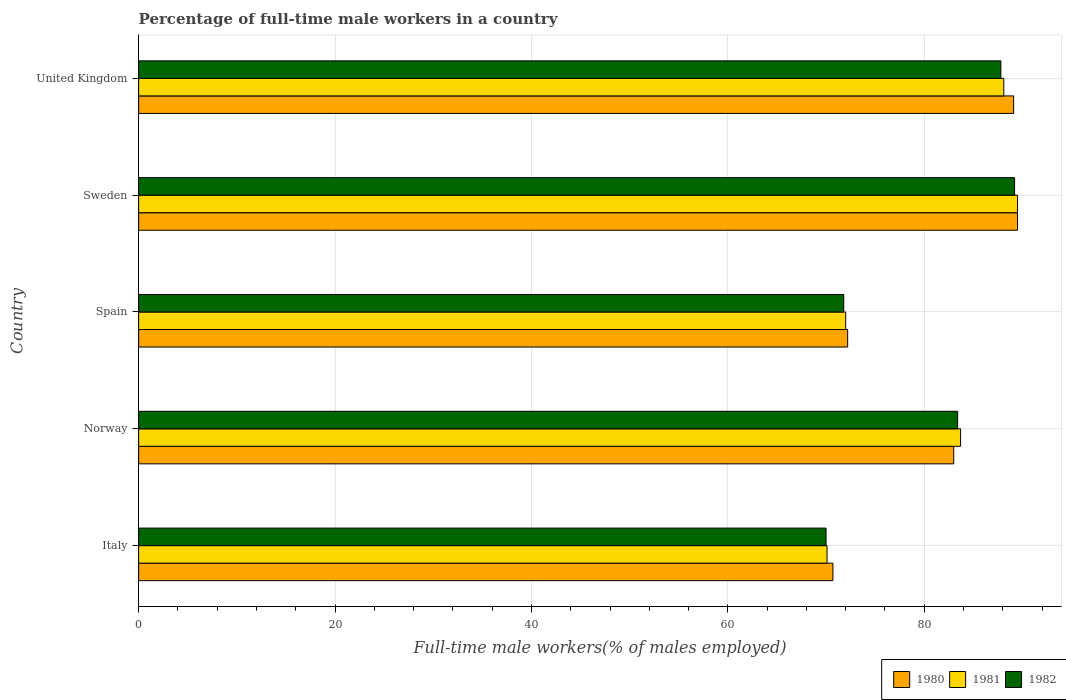How many different coloured bars are there?
Keep it short and to the point. 3. Are the number of bars per tick equal to the number of legend labels?
Give a very brief answer. Yes. Are the number of bars on each tick of the Y-axis equal?
Offer a very short reply. Yes. How many bars are there on the 2nd tick from the top?
Offer a terse response. 3. How many bars are there on the 3rd tick from the bottom?
Keep it short and to the point. 3. What is the percentage of full-time male workers in 1982 in Spain?
Provide a short and direct response. 71.8. Across all countries, what is the maximum percentage of full-time male workers in 1981?
Offer a terse response. 89.5. Across all countries, what is the minimum percentage of full-time male workers in 1981?
Offer a terse response. 70.1. In which country was the percentage of full-time male workers in 1981 maximum?
Your answer should be compact. Sweden. In which country was the percentage of full-time male workers in 1982 minimum?
Keep it short and to the point. Italy. What is the total percentage of full-time male workers in 1982 in the graph?
Offer a very short reply. 402.2. What is the difference between the percentage of full-time male workers in 1982 in Italy and that in Norway?
Offer a very short reply. -13.4. What is the difference between the percentage of full-time male workers in 1981 in Spain and the percentage of full-time male workers in 1982 in Sweden?
Give a very brief answer. -17.2. What is the average percentage of full-time male workers in 1981 per country?
Your response must be concise. 80.68. What is the difference between the percentage of full-time male workers in 1980 and percentage of full-time male workers in 1981 in Spain?
Make the answer very short. 0.2. In how many countries, is the percentage of full-time male workers in 1982 greater than 56 %?
Offer a very short reply. 5. What is the ratio of the percentage of full-time male workers in 1981 in Italy to that in Sweden?
Provide a succinct answer. 0.78. Is the percentage of full-time male workers in 1980 in Italy less than that in United Kingdom?
Make the answer very short. Yes. What is the difference between the highest and the second highest percentage of full-time male workers in 1981?
Ensure brevity in your answer.  1.4. What is the difference between the highest and the lowest percentage of full-time male workers in 1982?
Keep it short and to the point. 19.2. In how many countries, is the percentage of full-time male workers in 1981 greater than the average percentage of full-time male workers in 1981 taken over all countries?
Provide a succinct answer. 3. What does the 3rd bar from the bottom in Sweden represents?
Offer a very short reply. 1982. Are all the bars in the graph horizontal?
Your answer should be very brief. Yes. How many countries are there in the graph?
Give a very brief answer. 5. What is the difference between two consecutive major ticks on the X-axis?
Your response must be concise. 20. Does the graph contain grids?
Give a very brief answer. Yes. Where does the legend appear in the graph?
Provide a short and direct response. Bottom right. How many legend labels are there?
Give a very brief answer. 3. What is the title of the graph?
Your answer should be very brief. Percentage of full-time male workers in a country. Does "2012" appear as one of the legend labels in the graph?
Offer a very short reply. No. What is the label or title of the X-axis?
Give a very brief answer. Full-time male workers(% of males employed). What is the Full-time male workers(% of males employed) of 1980 in Italy?
Provide a succinct answer. 70.7. What is the Full-time male workers(% of males employed) of 1981 in Italy?
Offer a very short reply. 70.1. What is the Full-time male workers(% of males employed) of 1981 in Norway?
Offer a terse response. 83.7. What is the Full-time male workers(% of males employed) in 1982 in Norway?
Provide a succinct answer. 83.4. What is the Full-time male workers(% of males employed) in 1980 in Spain?
Offer a very short reply. 72.2. What is the Full-time male workers(% of males employed) of 1982 in Spain?
Your answer should be very brief. 71.8. What is the Full-time male workers(% of males employed) of 1980 in Sweden?
Your answer should be very brief. 89.5. What is the Full-time male workers(% of males employed) of 1981 in Sweden?
Provide a succinct answer. 89.5. What is the Full-time male workers(% of males employed) in 1982 in Sweden?
Your answer should be compact. 89.2. What is the Full-time male workers(% of males employed) in 1980 in United Kingdom?
Provide a short and direct response. 89.1. What is the Full-time male workers(% of males employed) in 1981 in United Kingdom?
Offer a very short reply. 88.1. What is the Full-time male workers(% of males employed) of 1982 in United Kingdom?
Keep it short and to the point. 87.8. Across all countries, what is the maximum Full-time male workers(% of males employed) in 1980?
Your response must be concise. 89.5. Across all countries, what is the maximum Full-time male workers(% of males employed) in 1981?
Give a very brief answer. 89.5. Across all countries, what is the maximum Full-time male workers(% of males employed) in 1982?
Provide a succinct answer. 89.2. Across all countries, what is the minimum Full-time male workers(% of males employed) of 1980?
Give a very brief answer. 70.7. Across all countries, what is the minimum Full-time male workers(% of males employed) in 1981?
Provide a succinct answer. 70.1. What is the total Full-time male workers(% of males employed) of 1980 in the graph?
Make the answer very short. 404.5. What is the total Full-time male workers(% of males employed) in 1981 in the graph?
Your response must be concise. 403.4. What is the total Full-time male workers(% of males employed) in 1982 in the graph?
Your answer should be very brief. 402.2. What is the difference between the Full-time male workers(% of males employed) of 1980 in Italy and that in Norway?
Ensure brevity in your answer.  -12.3. What is the difference between the Full-time male workers(% of males employed) in 1981 in Italy and that in Norway?
Your response must be concise. -13.6. What is the difference between the Full-time male workers(% of males employed) in 1982 in Italy and that in Norway?
Keep it short and to the point. -13.4. What is the difference between the Full-time male workers(% of males employed) of 1981 in Italy and that in Spain?
Your answer should be compact. -1.9. What is the difference between the Full-time male workers(% of males employed) of 1982 in Italy and that in Spain?
Provide a succinct answer. -1.8. What is the difference between the Full-time male workers(% of males employed) in 1980 in Italy and that in Sweden?
Offer a terse response. -18.8. What is the difference between the Full-time male workers(% of males employed) in 1981 in Italy and that in Sweden?
Make the answer very short. -19.4. What is the difference between the Full-time male workers(% of males employed) in 1982 in Italy and that in Sweden?
Offer a terse response. -19.2. What is the difference between the Full-time male workers(% of males employed) in 1980 in Italy and that in United Kingdom?
Keep it short and to the point. -18.4. What is the difference between the Full-time male workers(% of males employed) of 1981 in Italy and that in United Kingdom?
Make the answer very short. -18. What is the difference between the Full-time male workers(% of males employed) in 1982 in Italy and that in United Kingdom?
Offer a very short reply. -17.8. What is the difference between the Full-time male workers(% of males employed) in 1980 in Norway and that in Sweden?
Ensure brevity in your answer.  -6.5. What is the difference between the Full-time male workers(% of males employed) in 1981 in Norway and that in Sweden?
Give a very brief answer. -5.8. What is the difference between the Full-time male workers(% of males employed) of 1982 in Norway and that in Sweden?
Your response must be concise. -5.8. What is the difference between the Full-time male workers(% of males employed) of 1980 in Norway and that in United Kingdom?
Your answer should be very brief. -6.1. What is the difference between the Full-time male workers(% of males employed) of 1981 in Norway and that in United Kingdom?
Offer a very short reply. -4.4. What is the difference between the Full-time male workers(% of males employed) in 1980 in Spain and that in Sweden?
Keep it short and to the point. -17.3. What is the difference between the Full-time male workers(% of males employed) in 1981 in Spain and that in Sweden?
Provide a short and direct response. -17.5. What is the difference between the Full-time male workers(% of males employed) of 1982 in Spain and that in Sweden?
Ensure brevity in your answer.  -17.4. What is the difference between the Full-time male workers(% of males employed) in 1980 in Spain and that in United Kingdom?
Your answer should be very brief. -16.9. What is the difference between the Full-time male workers(% of males employed) in 1981 in Spain and that in United Kingdom?
Your response must be concise. -16.1. What is the difference between the Full-time male workers(% of males employed) of 1980 in Sweden and that in United Kingdom?
Give a very brief answer. 0.4. What is the difference between the Full-time male workers(% of males employed) in 1981 in Italy and the Full-time male workers(% of males employed) in 1982 in Norway?
Your answer should be very brief. -13.3. What is the difference between the Full-time male workers(% of males employed) in 1980 in Italy and the Full-time male workers(% of males employed) in 1981 in Spain?
Provide a succinct answer. -1.3. What is the difference between the Full-time male workers(% of males employed) in 1980 in Italy and the Full-time male workers(% of males employed) in 1982 in Spain?
Provide a succinct answer. -1.1. What is the difference between the Full-time male workers(% of males employed) of 1980 in Italy and the Full-time male workers(% of males employed) of 1981 in Sweden?
Offer a terse response. -18.8. What is the difference between the Full-time male workers(% of males employed) of 1980 in Italy and the Full-time male workers(% of males employed) of 1982 in Sweden?
Your answer should be compact. -18.5. What is the difference between the Full-time male workers(% of males employed) of 1981 in Italy and the Full-time male workers(% of males employed) of 1982 in Sweden?
Ensure brevity in your answer.  -19.1. What is the difference between the Full-time male workers(% of males employed) in 1980 in Italy and the Full-time male workers(% of males employed) in 1981 in United Kingdom?
Your response must be concise. -17.4. What is the difference between the Full-time male workers(% of males employed) in 1980 in Italy and the Full-time male workers(% of males employed) in 1982 in United Kingdom?
Make the answer very short. -17.1. What is the difference between the Full-time male workers(% of males employed) in 1981 in Italy and the Full-time male workers(% of males employed) in 1982 in United Kingdom?
Ensure brevity in your answer.  -17.7. What is the difference between the Full-time male workers(% of males employed) of 1981 in Norway and the Full-time male workers(% of males employed) of 1982 in Spain?
Provide a short and direct response. 11.9. What is the difference between the Full-time male workers(% of males employed) in 1981 in Norway and the Full-time male workers(% of males employed) in 1982 in Sweden?
Give a very brief answer. -5.5. What is the difference between the Full-time male workers(% of males employed) in 1980 in Norway and the Full-time male workers(% of males employed) in 1982 in United Kingdom?
Make the answer very short. -4.8. What is the difference between the Full-time male workers(% of males employed) in 1980 in Spain and the Full-time male workers(% of males employed) in 1981 in Sweden?
Ensure brevity in your answer.  -17.3. What is the difference between the Full-time male workers(% of males employed) in 1981 in Spain and the Full-time male workers(% of males employed) in 1982 in Sweden?
Your answer should be compact. -17.2. What is the difference between the Full-time male workers(% of males employed) in 1980 in Spain and the Full-time male workers(% of males employed) in 1981 in United Kingdom?
Offer a terse response. -15.9. What is the difference between the Full-time male workers(% of males employed) in 1980 in Spain and the Full-time male workers(% of males employed) in 1982 in United Kingdom?
Your answer should be compact. -15.6. What is the difference between the Full-time male workers(% of males employed) of 1981 in Spain and the Full-time male workers(% of males employed) of 1982 in United Kingdom?
Your response must be concise. -15.8. What is the average Full-time male workers(% of males employed) in 1980 per country?
Make the answer very short. 80.9. What is the average Full-time male workers(% of males employed) of 1981 per country?
Provide a short and direct response. 80.68. What is the average Full-time male workers(% of males employed) of 1982 per country?
Make the answer very short. 80.44. What is the difference between the Full-time male workers(% of males employed) in 1980 and Full-time male workers(% of males employed) in 1981 in Italy?
Your response must be concise. 0.6. What is the difference between the Full-time male workers(% of males employed) in 1980 and Full-time male workers(% of males employed) in 1982 in Norway?
Give a very brief answer. -0.4. What is the difference between the Full-time male workers(% of males employed) of 1980 and Full-time male workers(% of males employed) of 1981 in Sweden?
Provide a succinct answer. 0. What is the difference between the Full-time male workers(% of males employed) of 1980 and Full-time male workers(% of males employed) of 1981 in United Kingdom?
Offer a terse response. 1. What is the difference between the Full-time male workers(% of males employed) of 1980 and Full-time male workers(% of males employed) of 1982 in United Kingdom?
Provide a succinct answer. 1.3. What is the difference between the Full-time male workers(% of males employed) of 1981 and Full-time male workers(% of males employed) of 1982 in United Kingdom?
Provide a short and direct response. 0.3. What is the ratio of the Full-time male workers(% of males employed) of 1980 in Italy to that in Norway?
Keep it short and to the point. 0.85. What is the ratio of the Full-time male workers(% of males employed) of 1981 in Italy to that in Norway?
Offer a terse response. 0.84. What is the ratio of the Full-time male workers(% of males employed) of 1982 in Italy to that in Norway?
Give a very brief answer. 0.84. What is the ratio of the Full-time male workers(% of males employed) of 1980 in Italy to that in Spain?
Your response must be concise. 0.98. What is the ratio of the Full-time male workers(% of males employed) in 1981 in Italy to that in Spain?
Give a very brief answer. 0.97. What is the ratio of the Full-time male workers(% of males employed) of 1982 in Italy to that in Spain?
Provide a short and direct response. 0.97. What is the ratio of the Full-time male workers(% of males employed) of 1980 in Italy to that in Sweden?
Provide a succinct answer. 0.79. What is the ratio of the Full-time male workers(% of males employed) in 1981 in Italy to that in Sweden?
Keep it short and to the point. 0.78. What is the ratio of the Full-time male workers(% of males employed) of 1982 in Italy to that in Sweden?
Provide a short and direct response. 0.78. What is the ratio of the Full-time male workers(% of males employed) in 1980 in Italy to that in United Kingdom?
Give a very brief answer. 0.79. What is the ratio of the Full-time male workers(% of males employed) in 1981 in Italy to that in United Kingdom?
Your answer should be compact. 0.8. What is the ratio of the Full-time male workers(% of males employed) of 1982 in Italy to that in United Kingdom?
Make the answer very short. 0.8. What is the ratio of the Full-time male workers(% of males employed) in 1980 in Norway to that in Spain?
Your response must be concise. 1.15. What is the ratio of the Full-time male workers(% of males employed) of 1981 in Norway to that in Spain?
Offer a very short reply. 1.16. What is the ratio of the Full-time male workers(% of males employed) of 1982 in Norway to that in Spain?
Give a very brief answer. 1.16. What is the ratio of the Full-time male workers(% of males employed) in 1980 in Norway to that in Sweden?
Give a very brief answer. 0.93. What is the ratio of the Full-time male workers(% of males employed) in 1981 in Norway to that in Sweden?
Provide a succinct answer. 0.94. What is the ratio of the Full-time male workers(% of males employed) of 1982 in Norway to that in Sweden?
Your response must be concise. 0.94. What is the ratio of the Full-time male workers(% of males employed) of 1980 in Norway to that in United Kingdom?
Keep it short and to the point. 0.93. What is the ratio of the Full-time male workers(% of males employed) in 1981 in Norway to that in United Kingdom?
Provide a succinct answer. 0.95. What is the ratio of the Full-time male workers(% of males employed) of 1982 in Norway to that in United Kingdom?
Your answer should be compact. 0.95. What is the ratio of the Full-time male workers(% of males employed) of 1980 in Spain to that in Sweden?
Your answer should be compact. 0.81. What is the ratio of the Full-time male workers(% of males employed) of 1981 in Spain to that in Sweden?
Give a very brief answer. 0.8. What is the ratio of the Full-time male workers(% of males employed) of 1982 in Spain to that in Sweden?
Your response must be concise. 0.8. What is the ratio of the Full-time male workers(% of males employed) in 1980 in Spain to that in United Kingdom?
Your answer should be very brief. 0.81. What is the ratio of the Full-time male workers(% of males employed) of 1981 in Spain to that in United Kingdom?
Keep it short and to the point. 0.82. What is the ratio of the Full-time male workers(% of males employed) of 1982 in Spain to that in United Kingdom?
Your answer should be compact. 0.82. What is the ratio of the Full-time male workers(% of males employed) of 1981 in Sweden to that in United Kingdom?
Your response must be concise. 1.02. What is the ratio of the Full-time male workers(% of males employed) in 1982 in Sweden to that in United Kingdom?
Offer a very short reply. 1.02. What is the difference between the highest and the second highest Full-time male workers(% of males employed) in 1981?
Provide a short and direct response. 1.4. What is the difference between the highest and the lowest Full-time male workers(% of males employed) of 1980?
Your answer should be very brief. 18.8. What is the difference between the highest and the lowest Full-time male workers(% of males employed) of 1982?
Your answer should be very brief. 19.2. 